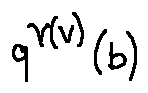Convert formula to latex. <formula><loc_0><loc_0><loc_500><loc_500>q ^ { \gamma ( v ) } ( b )</formula> 